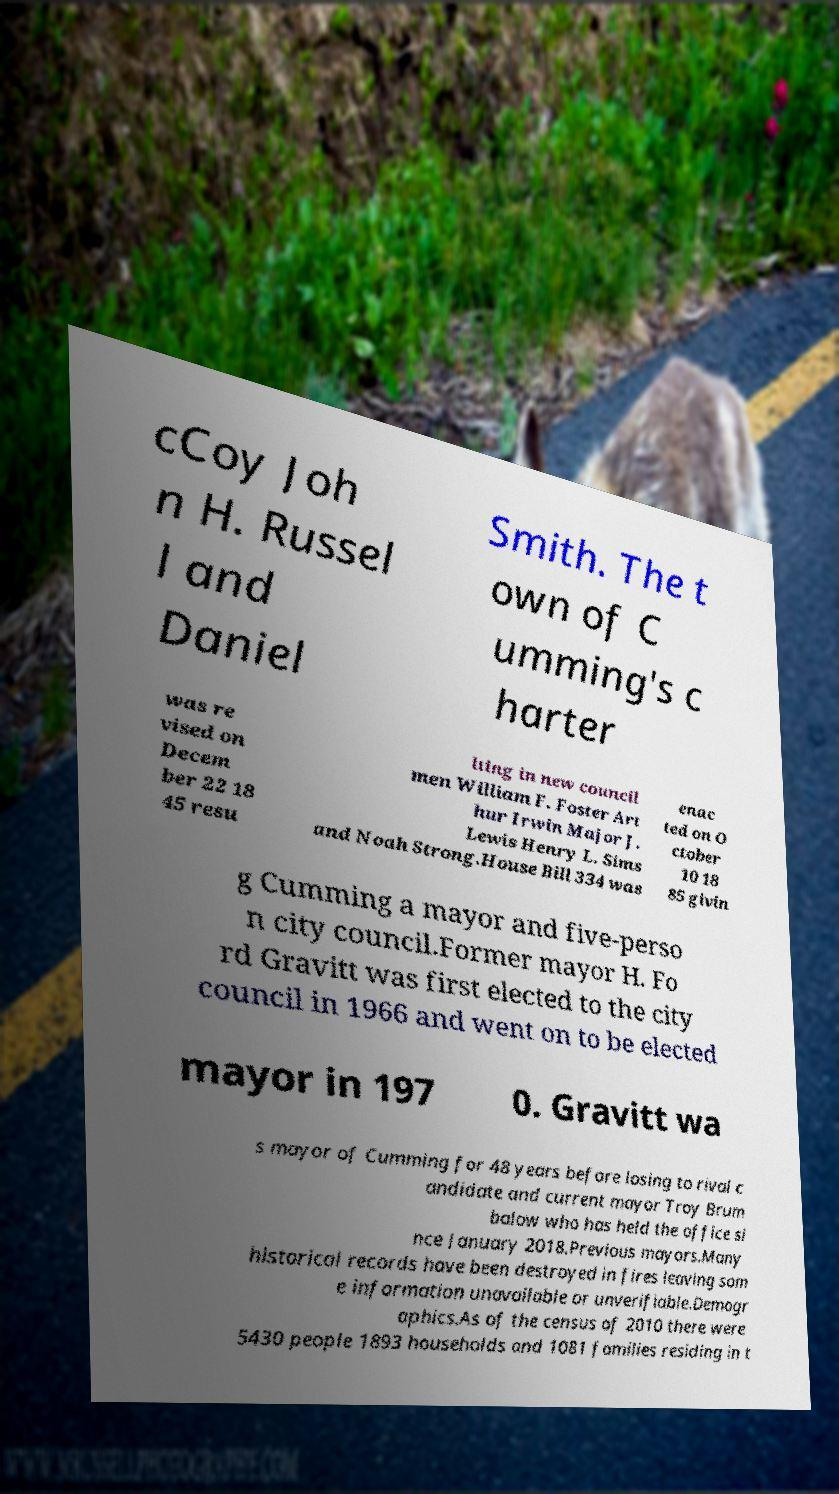I need the written content from this picture converted into text. Can you do that? cCoy Joh n H. Russel l and Daniel Smith. The t own of C umming's c harter was re vised on Decem ber 22 18 45 resu lting in new council men William F. Foster Art hur Irwin Major J. Lewis Henry L. Sims and Noah Strong.House Bill 334 was enac ted on O ctober 10 18 85 givin g Cumming a mayor and five-perso n city council.Former mayor H. Fo rd Gravitt was first elected to the city council in 1966 and went on to be elected mayor in 197 0. Gravitt wa s mayor of Cumming for 48 years before losing to rival c andidate and current mayor Troy Brum balow who has held the office si nce January 2018.Previous mayors.Many historical records have been destroyed in fires leaving som e information unavailable or unverifiable.Demogr aphics.As of the census of 2010 there were 5430 people 1893 households and 1081 families residing in t 